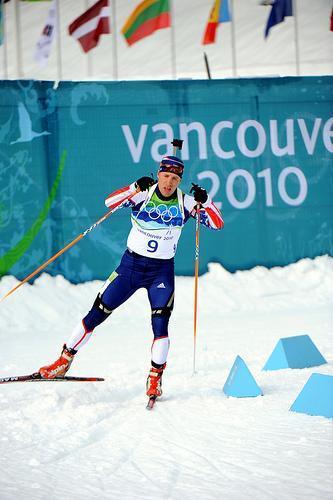How many men are in the photo?
Give a very brief answer. 1. 